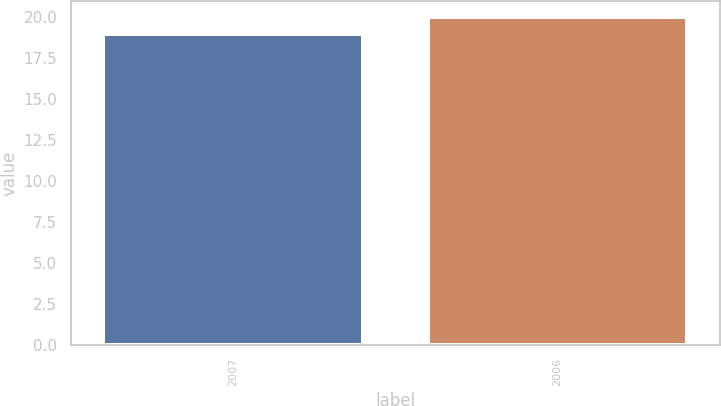<chart> <loc_0><loc_0><loc_500><loc_500><bar_chart><fcel>2007<fcel>2006<nl><fcel>19<fcel>20<nl></chart> 